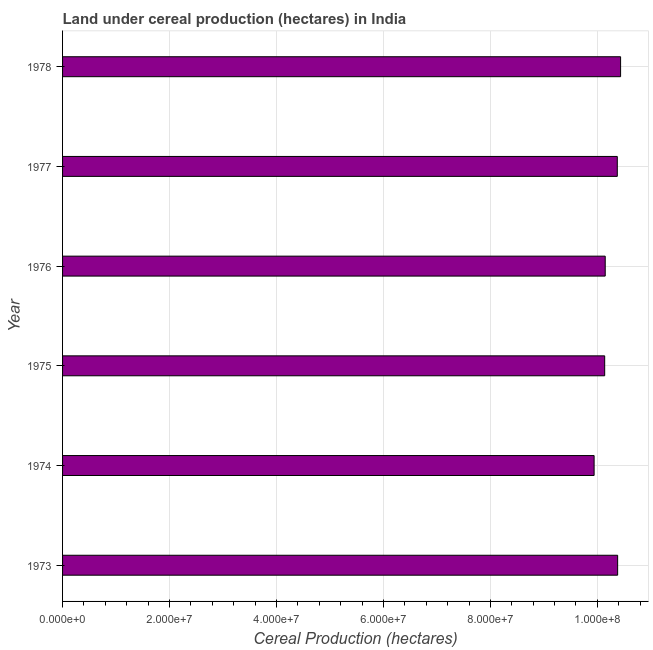Does the graph contain any zero values?
Your answer should be compact. No. What is the title of the graph?
Provide a short and direct response. Land under cereal production (hectares) in India. What is the label or title of the X-axis?
Provide a succinct answer. Cereal Production (hectares). What is the land under cereal production in 1973?
Keep it short and to the point. 1.04e+08. Across all years, what is the maximum land under cereal production?
Ensure brevity in your answer.  1.04e+08. Across all years, what is the minimum land under cereal production?
Provide a short and direct response. 9.94e+07. In which year was the land under cereal production maximum?
Keep it short and to the point. 1978. In which year was the land under cereal production minimum?
Your answer should be very brief. 1974. What is the sum of the land under cereal production?
Your answer should be compact. 6.14e+08. What is the difference between the land under cereal production in 1974 and 1975?
Offer a terse response. -1.98e+06. What is the average land under cereal production per year?
Your answer should be very brief. 1.02e+08. What is the median land under cereal production?
Give a very brief answer. 1.03e+08. Is the land under cereal production in 1975 less than that in 1978?
Your answer should be compact. Yes. Is the difference between the land under cereal production in 1976 and 1978 greater than the difference between any two years?
Provide a succinct answer. No. What is the difference between the highest and the second highest land under cereal production?
Keep it short and to the point. 5.51e+05. What is the difference between the highest and the lowest land under cereal production?
Your answer should be compact. 4.95e+06. How many bars are there?
Ensure brevity in your answer.  6. Are all the bars in the graph horizontal?
Provide a short and direct response. Yes. How many years are there in the graph?
Provide a succinct answer. 6. What is the Cereal Production (hectares) of 1973?
Your response must be concise. 1.04e+08. What is the Cereal Production (hectares) in 1974?
Your response must be concise. 9.94e+07. What is the Cereal Production (hectares) in 1975?
Offer a very short reply. 1.01e+08. What is the Cereal Production (hectares) in 1976?
Keep it short and to the point. 1.01e+08. What is the Cereal Production (hectares) of 1977?
Ensure brevity in your answer.  1.04e+08. What is the Cereal Production (hectares) of 1978?
Offer a terse response. 1.04e+08. What is the difference between the Cereal Production (hectares) in 1973 and 1974?
Keep it short and to the point. 4.40e+06. What is the difference between the Cereal Production (hectares) in 1973 and 1975?
Your answer should be very brief. 2.42e+06. What is the difference between the Cereal Production (hectares) in 1973 and 1976?
Provide a short and direct response. 2.32e+06. What is the difference between the Cereal Production (hectares) in 1973 and 1977?
Ensure brevity in your answer.  6.53e+04. What is the difference between the Cereal Production (hectares) in 1973 and 1978?
Ensure brevity in your answer.  -5.51e+05. What is the difference between the Cereal Production (hectares) in 1974 and 1975?
Your answer should be very brief. -1.98e+06. What is the difference between the Cereal Production (hectares) in 1974 and 1976?
Provide a short and direct response. -2.08e+06. What is the difference between the Cereal Production (hectares) in 1974 and 1977?
Your response must be concise. -4.33e+06. What is the difference between the Cereal Production (hectares) in 1974 and 1978?
Offer a terse response. -4.95e+06. What is the difference between the Cereal Production (hectares) in 1975 and 1976?
Your response must be concise. -9.82e+04. What is the difference between the Cereal Production (hectares) in 1975 and 1977?
Provide a short and direct response. -2.36e+06. What is the difference between the Cereal Production (hectares) in 1975 and 1978?
Give a very brief answer. -2.97e+06. What is the difference between the Cereal Production (hectares) in 1976 and 1977?
Keep it short and to the point. -2.26e+06. What is the difference between the Cereal Production (hectares) in 1976 and 1978?
Make the answer very short. -2.87e+06. What is the difference between the Cereal Production (hectares) in 1977 and 1978?
Ensure brevity in your answer.  -6.16e+05. What is the ratio of the Cereal Production (hectares) in 1973 to that in 1974?
Offer a terse response. 1.04. What is the ratio of the Cereal Production (hectares) in 1973 to that in 1977?
Keep it short and to the point. 1. What is the ratio of the Cereal Production (hectares) in 1973 to that in 1978?
Offer a very short reply. 0.99. What is the ratio of the Cereal Production (hectares) in 1974 to that in 1976?
Give a very brief answer. 0.98. What is the ratio of the Cereal Production (hectares) in 1974 to that in 1977?
Keep it short and to the point. 0.96. What is the ratio of the Cereal Production (hectares) in 1974 to that in 1978?
Make the answer very short. 0.95. What is the ratio of the Cereal Production (hectares) in 1976 to that in 1978?
Your answer should be compact. 0.97. 